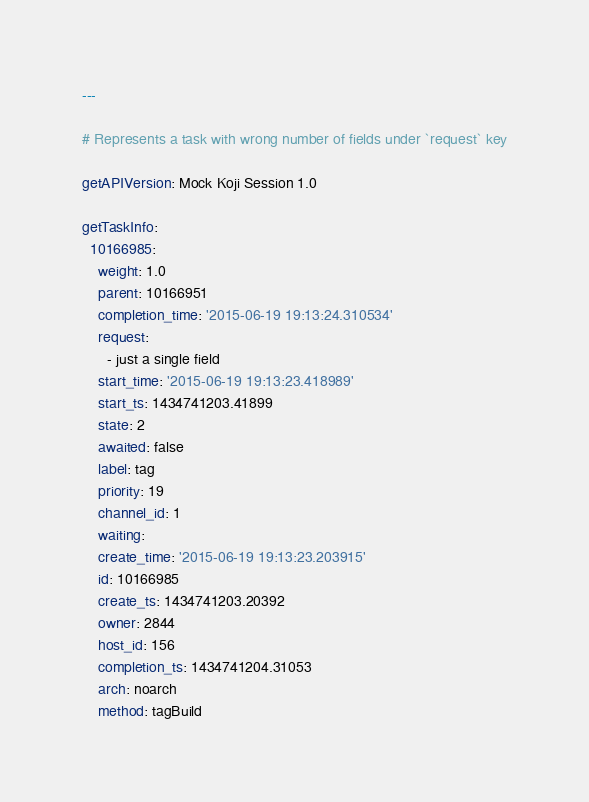Convert code to text. <code><loc_0><loc_0><loc_500><loc_500><_YAML_>---

# Represents a task with wrong number of fields under `request` key

getAPIVersion: Mock Koji Session 1.0

getTaskInfo:
  10166985:
    weight: 1.0
    parent: 10166951
    completion_time: '2015-06-19 19:13:24.310534'
    request:
      - just a single field
    start_time: '2015-06-19 19:13:23.418989'
    start_ts: 1434741203.41899
    state: 2
    awaited: false
    label: tag
    priority: 19
    channel_id: 1
    waiting:
    create_time: '2015-06-19 19:13:23.203915'
    id: 10166985
    create_ts: 1434741203.20392
    owner: 2844
    host_id: 156
    completion_ts: 1434741204.31053
    arch: noarch
    method: tagBuild
</code> 